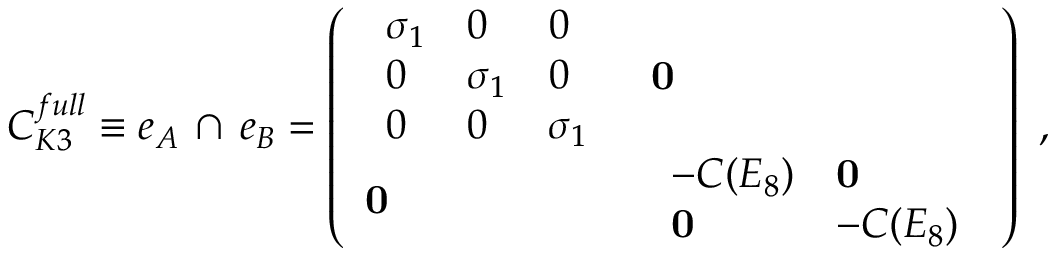<formula> <loc_0><loc_0><loc_500><loc_500>C _ { K 3 } ^ { f u l l } \equiv e _ { A } \, \cap \, e _ { B } = \left ( \begin{array} { l l } { { \begin{array} { l l l } { { \sigma _ { 1 } } } & { 0 } & { 0 } \\ { 0 } & { { \sigma _ { 1 } } } & { 0 } \\ { 0 } & { 0 } & { { \sigma _ { 1 } } } \end{array} } } & { 0 } \\ { 0 } & { { \begin{array} { l l } { { - C ( E _ { 8 } ) } } & { 0 } \\ { 0 } & { { - C ( E _ { 8 } ) } } \end{array} } } \end{array} \right ) \ ,</formula> 